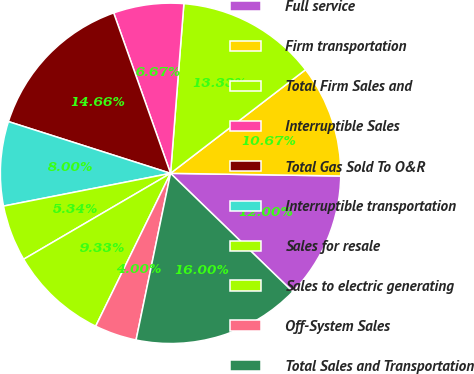Convert chart. <chart><loc_0><loc_0><loc_500><loc_500><pie_chart><fcel>Full service<fcel>Firm transportation<fcel>Total Firm Sales and<fcel>Interruptible Sales<fcel>Total Gas Sold To O&R<fcel>Interruptible transportation<fcel>Sales for resale<fcel>Sales to electric generating<fcel>Off-System Sales<fcel>Total Sales and Transportation<nl><fcel>12.0%<fcel>10.67%<fcel>13.33%<fcel>6.67%<fcel>14.66%<fcel>8.0%<fcel>5.34%<fcel>9.33%<fcel>4.0%<fcel>16.0%<nl></chart> 